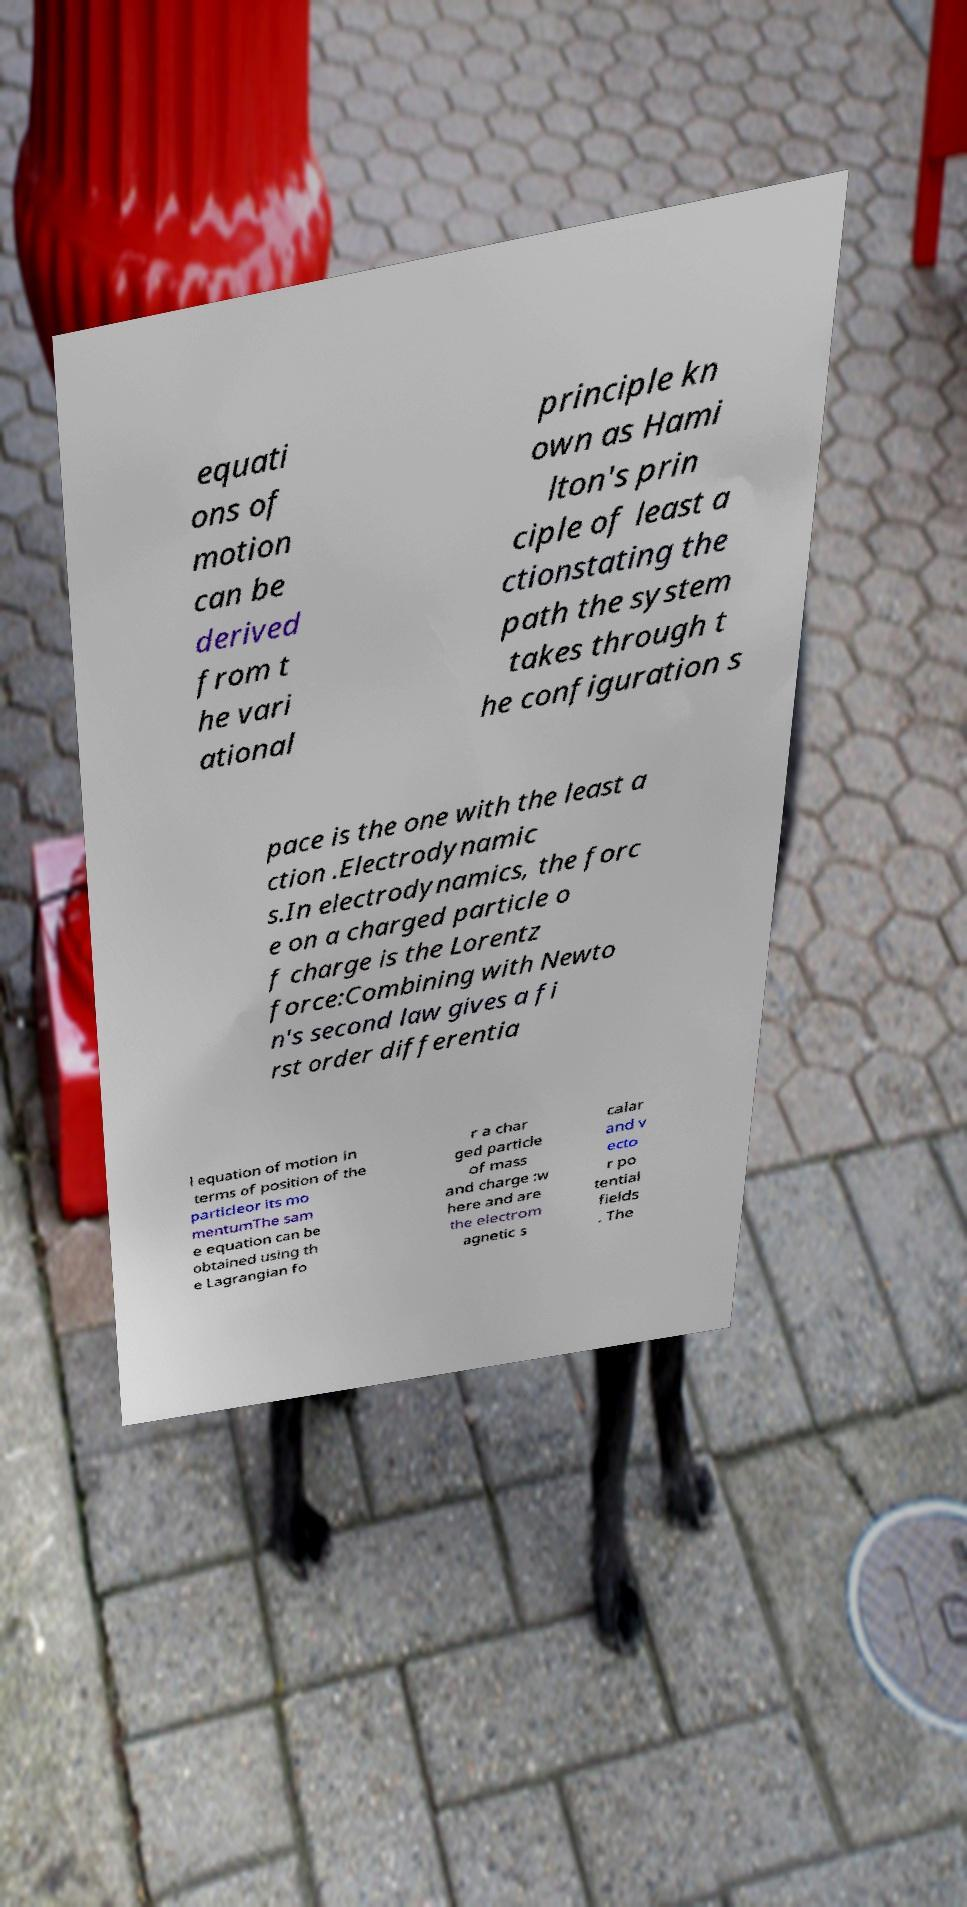There's text embedded in this image that I need extracted. Can you transcribe it verbatim? equati ons of motion can be derived from t he vari ational principle kn own as Hami lton's prin ciple of least a ctionstating the path the system takes through t he configuration s pace is the one with the least a ction .Electrodynamic s.In electrodynamics, the forc e on a charged particle o f charge is the Lorentz force:Combining with Newto n's second law gives a fi rst order differentia l equation of motion in terms of position of the particleor its mo mentumThe sam e equation can be obtained using th e Lagrangian fo r a char ged particle of mass and charge :w here and are the electrom agnetic s calar and v ecto r po tential fields . The 